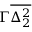Convert formula to latex. <formula><loc_0><loc_0><loc_500><loc_500>\Gamma \overline { { \Delta _ { 2 } ^ { 2 } } }</formula> 